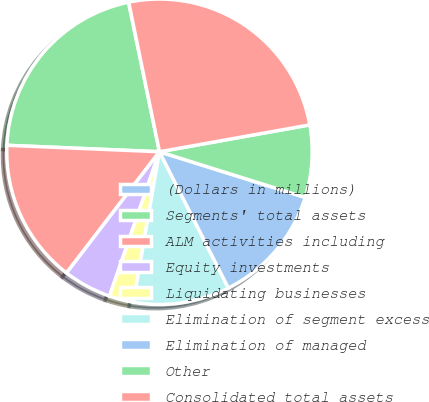Convert chart to OTSL. <chart><loc_0><loc_0><loc_500><loc_500><pie_chart><fcel>(Dollars in millions)<fcel>Segments' total assets<fcel>ALM activities including<fcel>Equity investments<fcel>Liquidating businesses<fcel>Elimination of segment excess<fcel>Elimination of managed<fcel>Other<fcel>Consolidated total assets<nl><fcel>0.03%<fcel>21.07%<fcel>15.26%<fcel>5.11%<fcel>2.57%<fcel>10.18%<fcel>12.72%<fcel>7.65%<fcel>25.41%<nl></chart> 